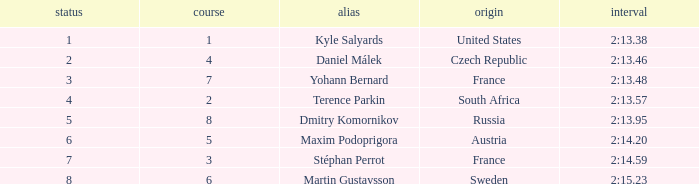What was Maxim Podoprigora's lowest rank? 6.0. 